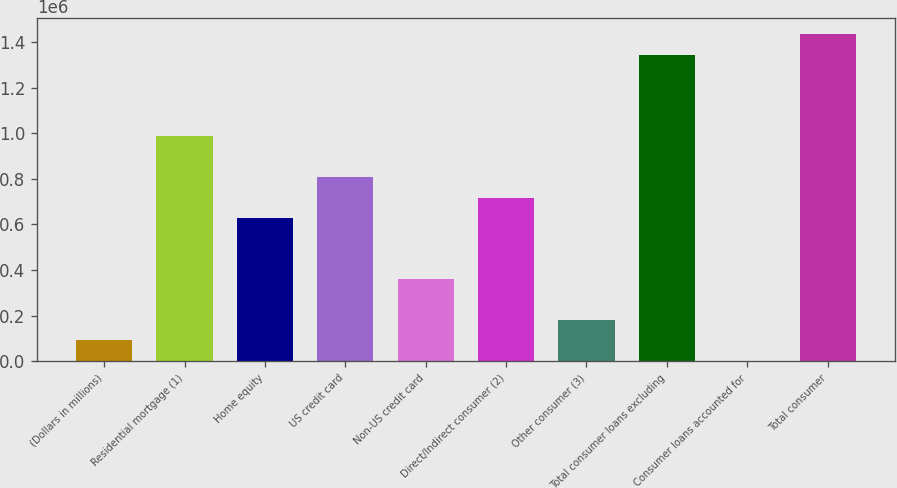Convert chart to OTSL. <chart><loc_0><loc_0><loc_500><loc_500><bar_chart><fcel>(Dollars in millions)<fcel>Residential mortgage (1)<fcel>Home equity<fcel>US credit card<fcel>Non-US credit card<fcel>Direct/Indirect consumer (2)<fcel>Other consumer (3)<fcel>Total consumer loans excluding<fcel>Consumer loans accounted for<fcel>Total consumer<nl><fcel>91382.2<fcel>986494<fcel>628449<fcel>807472<fcel>359916<fcel>717961<fcel>180893<fcel>1.34454e+06<fcel>1871<fcel>1.43405e+06<nl></chart> 